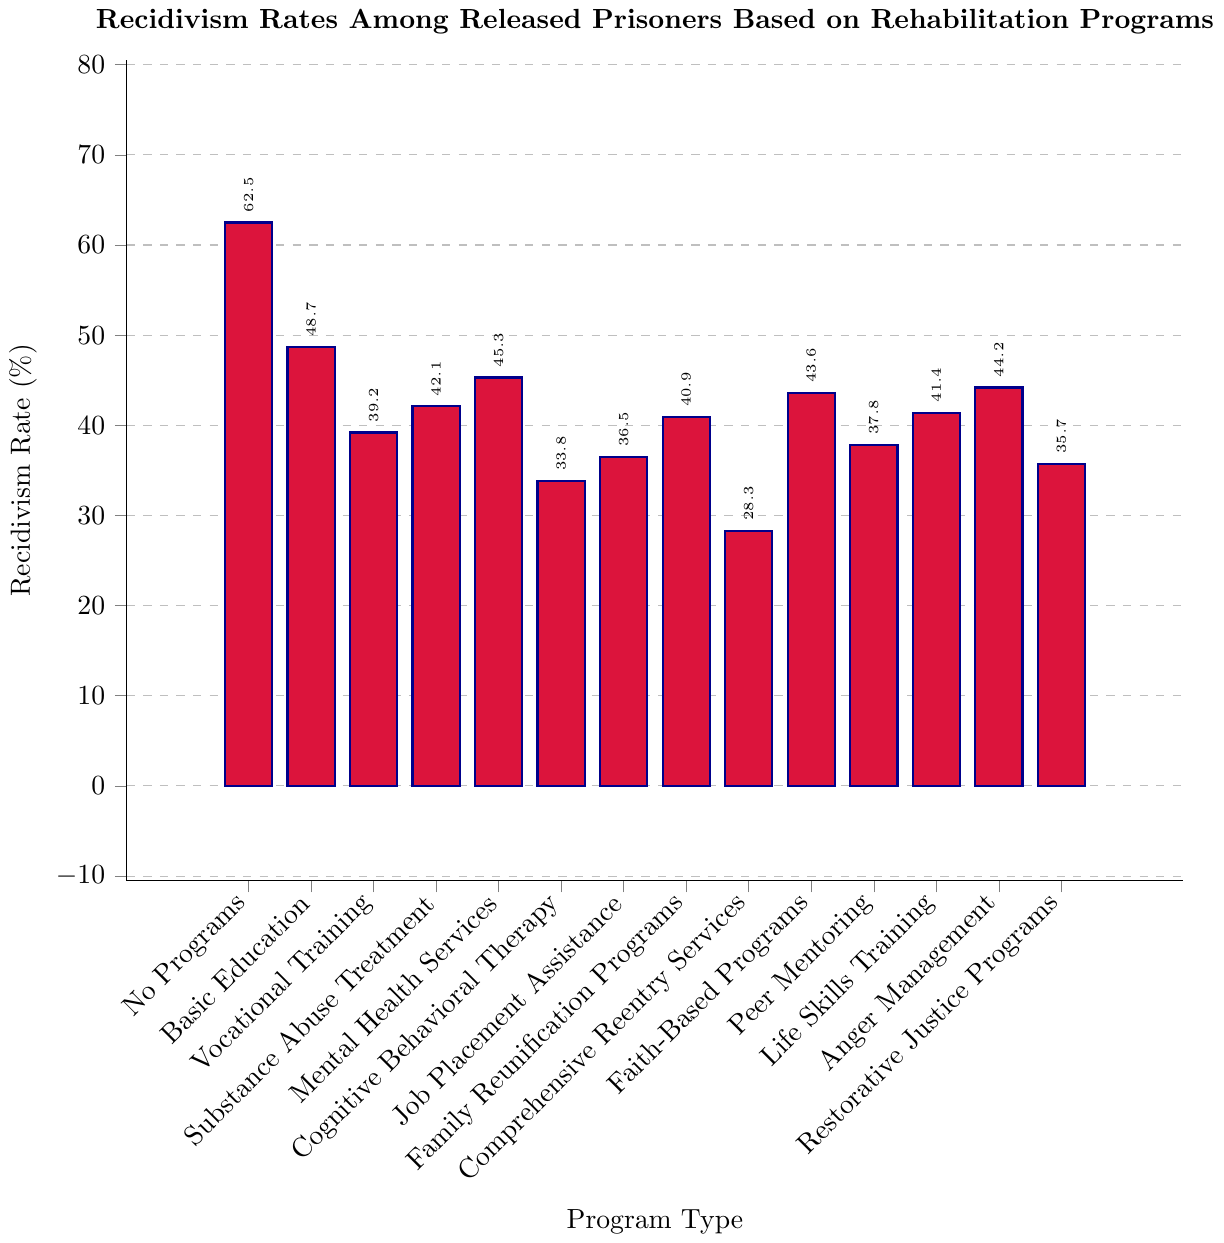What's the recidivism rate for prisoners who received Vocational Training? Check the bar labeled "Vocational Training" and read the value at the top.
Answer: 39.2% Which program has the highest recidivism rate? Identify the tallest bar from the figure, which represents the highest value.
Answer: No Programs Which program resulted in the lowest recidivism rate? Find the shortest bar from the figure, which corresponds to the lowest value.
Answer: Comprehensive Reentry Services How much lower is the recidivism rate for prisoners who had Cognitive Behavioral Therapy compared to those who had Anger Management? Subtract the recidivism rate of Cognitive Behavioral Therapy (33.8%) from the rate of Anger Management (44.2%).
Answer: 10.4% What is the recidivism rate gap between No Programs and Comprehensive Reentry Services? Subtract the rate of Comprehensive Reentry Services (28.3%) from the rate of No Programs (62.5%).
Answer: 34.2% Which program, between Basic Education and Faith-Based Programs, has a lower recidivism rate? Compare the bars of Basic Education (48.7%) and Faith-Based Programs (43.6%), and determine which value is lower.
Answer: Faith-Based Programs Is the recidivism rate of Peer Mentoring higher or lower than that of Job Placement Assistance? Compare the heights of the bars for Peer Mentoring (37.8%) and Job Placement Assistance (36.5%), and determine whether it is higher or lower.
Answer: Higher What's the average recidivism rate for Substance Abuse Treatment, Mental Health Services, and Anger Management? Sum up the recidivism rates (42.1 + 45.3 + 44.2) and divide by 3 to find the average. Average = (42.1 + 45.3 + 44.2)/3
Answer: 43.87% Are all programs' recidivism rates below the rate of No Programs? Compare each program’s recidivism rate against the No Programs rate of 62.5% to ensure they are all lower.
Answer: Yes Which three programs have recidivism rates below 35%? Identify the bars with values below 35%.
Answer: Cognitive Behavioral Therapy, Comprehensive Reentry Services, Restorative Justice Programs 